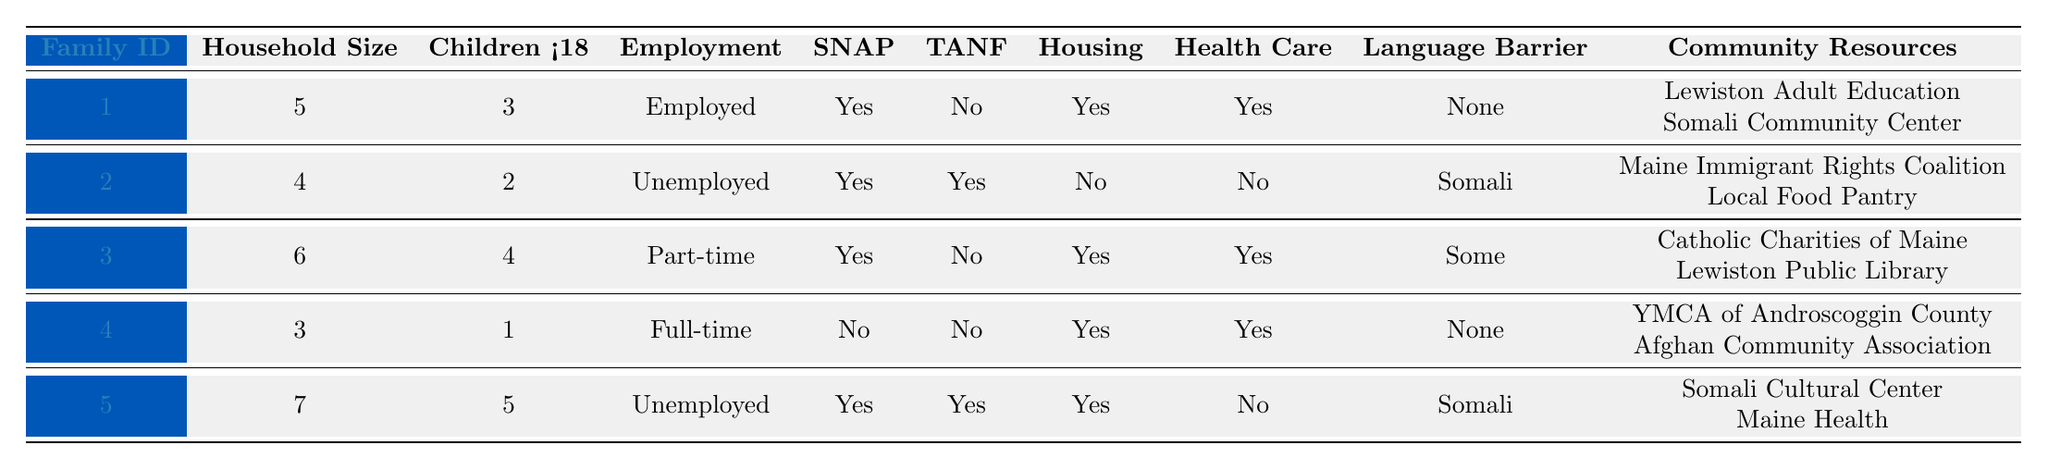What is the household size of Family ID 1? The table shows that Family ID 1 has a household size value listed under that column, which is 5.
Answer: 5 How many families have access to SNAP benefits? By looking at the "Access to SNAP" column, we see that families with IDs 1, 2, 3, and 5 have access, totaling 4 families.
Answer: 4 What is the employment status of Family ID 4? The employment status of Family ID 4 is listed in the "Employment" column, which indicates "Full-time."
Answer: Full-time Does Family ID 2 have access to housing assistance? The "Access to Housing Assistance" column shows that Family ID 2 is marked as "No," meaning they do not have access.
Answer: No How many children aged under 18 are in Family ID 5? The "Children <18" column for Family ID 5 shows the value 5, indicating that there are 5 children aged under 18.
Answer: 5 What is the total number of households represented in this data? There are 5 distinct entries, or rows, showing the data for 5 different families, indicating the total number of households is 5.
Answer: 5 Which family has no access to health care? Looking at the "Access to Health Care" column, we find Family ID 2 and Family ID 5, both marked as "No," indicating they do not have access.
Answer: Family ID 2 and Family ID 5 What is the average household size of all the families? The household sizes are 5, 4, 6, 3, and 7, totaling 25. Dividing by the number of families (5) gives 25/5 = 5.
Answer: 5 How many families have a language barrier? Based on the "Language Barrier" column, families 2 and 5 have a barrier reported as "Somali," while families 1, 3, and 4 reported "None" or "Some," so there are 2 families with a language barrier.
Answer: 2 Which families utilize the Somali Cultural Center? Family ID 5 lists the Somali Cultural Center in the "Community Resources" section, indicating they utilize this resource.
Answer: Family ID 5 Which family has both access to housing assistance and employed members? Family ID 1 and Family ID 4 have access to housing assistance while Family ID 1 has an employed member (Employed) and Family ID 4 has a full-time status; therefore, Family ID 1 is a match.
Answer: Family ID 1 What is the language barrier status of Family ID 3? The "Language Barrier" column shows that Family ID 3 has a status of "Some," indicating that there is a partial barrier.
Answer: Some How many families have both access to TANF and health care? Checking the columns, only Family ID 2 has access to TANF and is not accessing health care. Thus, there are zero families that have both TANF and health care.
Answer: 0 